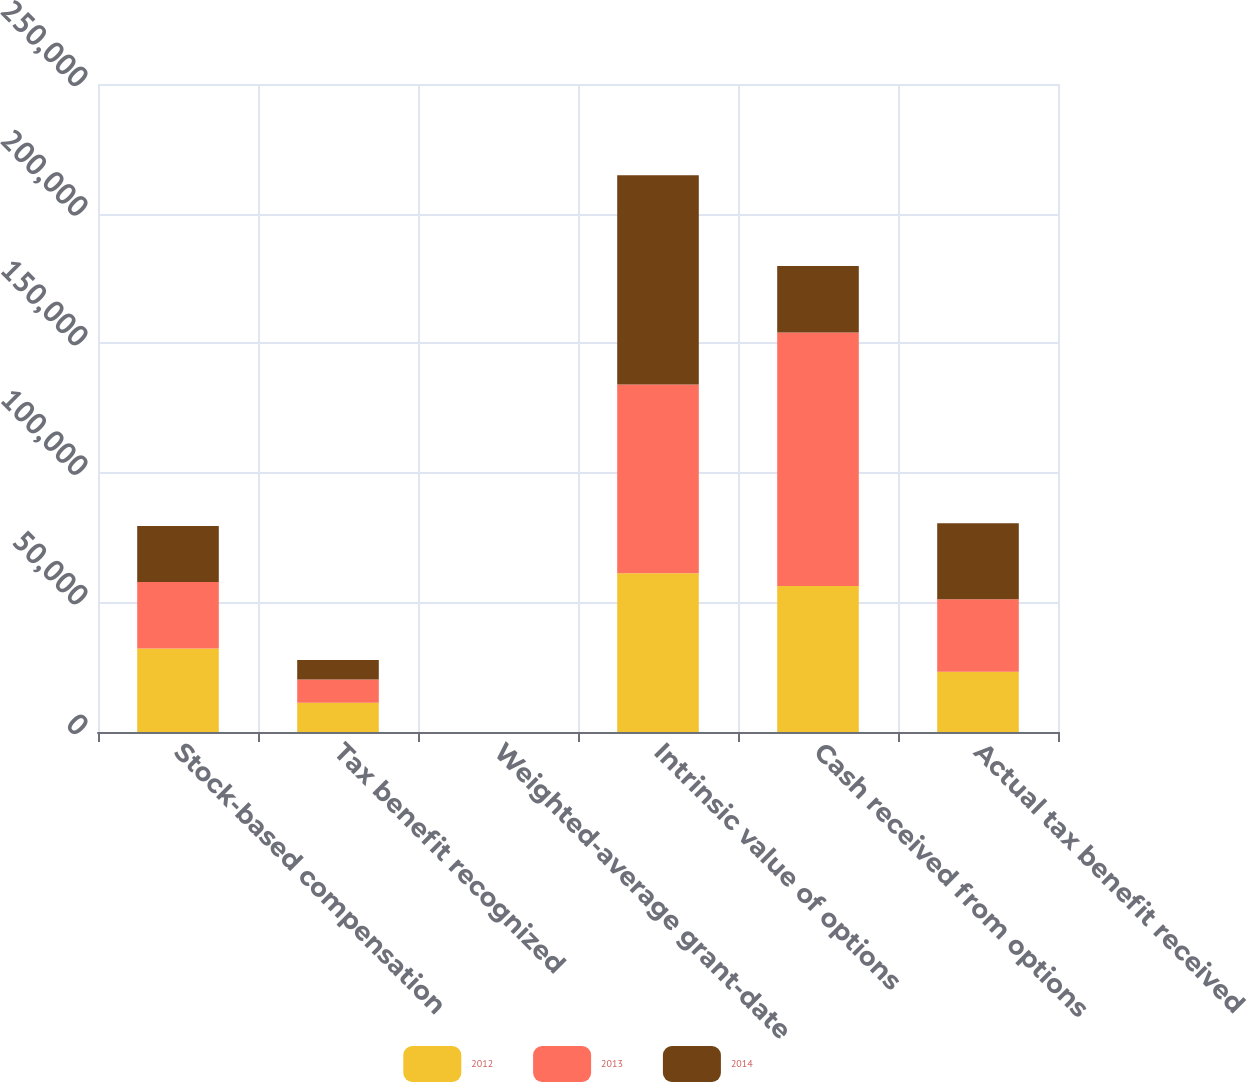<chart> <loc_0><loc_0><loc_500><loc_500><stacked_bar_chart><ecel><fcel>Stock-based compensation<fcel>Tax benefit recognized<fcel>Weighted-average grant-date<fcel>Intrinsic value of options<fcel>Cash received from options<fcel>Actual tax benefit received<nl><fcel>2012<fcel>32203<fcel>11271<fcel>14.77<fcel>61229<fcel>56294<fcel>23232<nl><fcel>2013<fcel>25642<fcel>8975<fcel>12.37<fcel>72793<fcel>97815<fcel>27972<nl><fcel>2014<fcel>21605<fcel>7562<fcel>10.47<fcel>80781<fcel>25642<fcel>29307<nl></chart> 